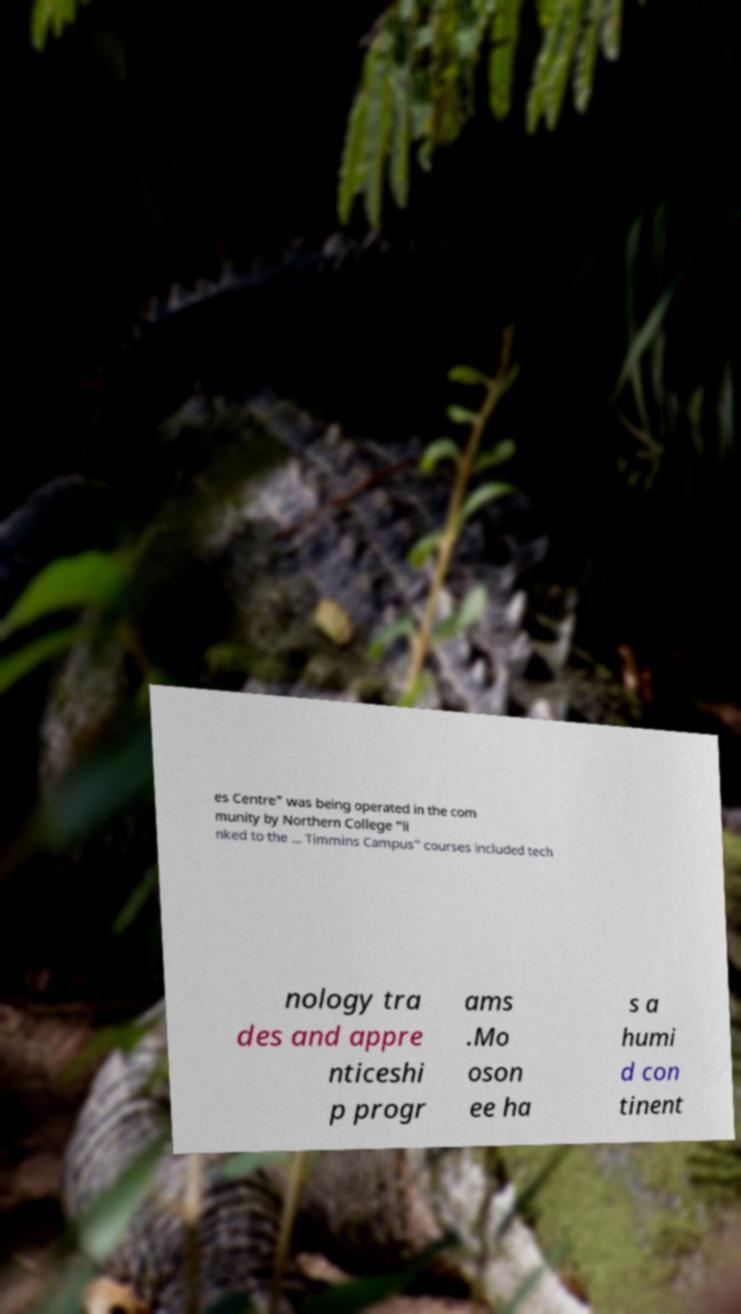Please read and relay the text visible in this image. What does it say? es Centre" was being operated in the com munity by Northern College "li nked to the ... Timmins Campus" courses included tech nology tra des and appre nticeshi p progr ams .Mo oson ee ha s a humi d con tinent 